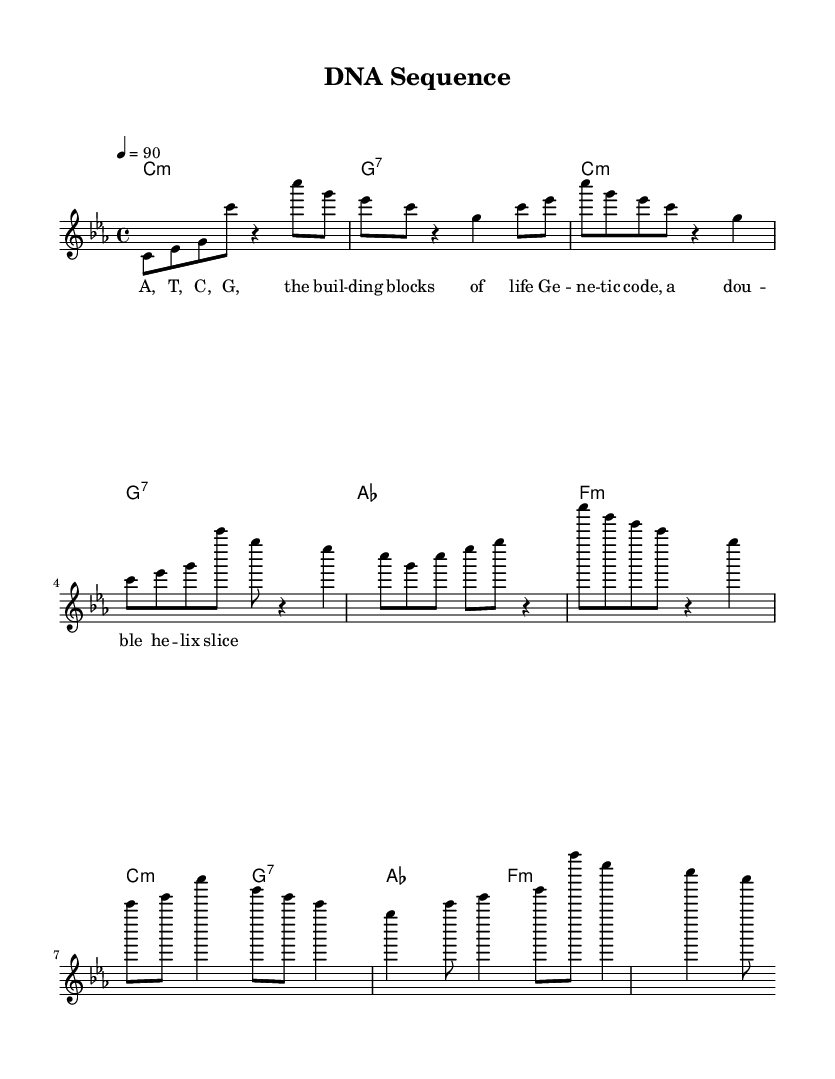What is the key signature of this music? The music is in C minor, which has three flats: B flat, E flat, and A flat. The key signature is located at the beginning of the staff.
Answer: C minor What is the time signature of this music? The time signature is indicated as 4/4, which means there are four beats in each measure and the quarter note receives one beat. This can be seen next to the clef at the beginning of the score.
Answer: 4/4 What is the tempo marking for this piece? The tempo marking is indicated with "4 = 90," meaning there are 90 beats per minute with a quarter note equating to one beat. This is located near the top of the score.
Answer: 90 How many measures are in the chorus section? The chorus section consists of two measures as indicated by the grouping of the notes directly beneath the lyrics and corresponding chords. Counting these reveals there are specifically two measures.
Answer: 2 What is the primary theme of the lyrics in this piece? The lyrics focus on the basic components of DNA, specifically referring to the building blocks of life (A, T, C, G) and the double helix structure, which is central to the theme of genetics and molecular biology.
Answer: Genetic code What is the starting note of the verse melody? The verse melody begins on the note C, which can be seen in the first note of the melody section labeled "melody." It is the fifth note in the sequence of the first bar of the verse.
Answer: C What type of chord is used in the first measure? The first measure features a C minor chord, which is indicated by the chord symbol "c:m" in the harmonies section. This implies that the root note is C and it is a minor triad.
Answer: C minor 